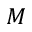Convert formula to latex. <formula><loc_0><loc_0><loc_500><loc_500>M</formula> 